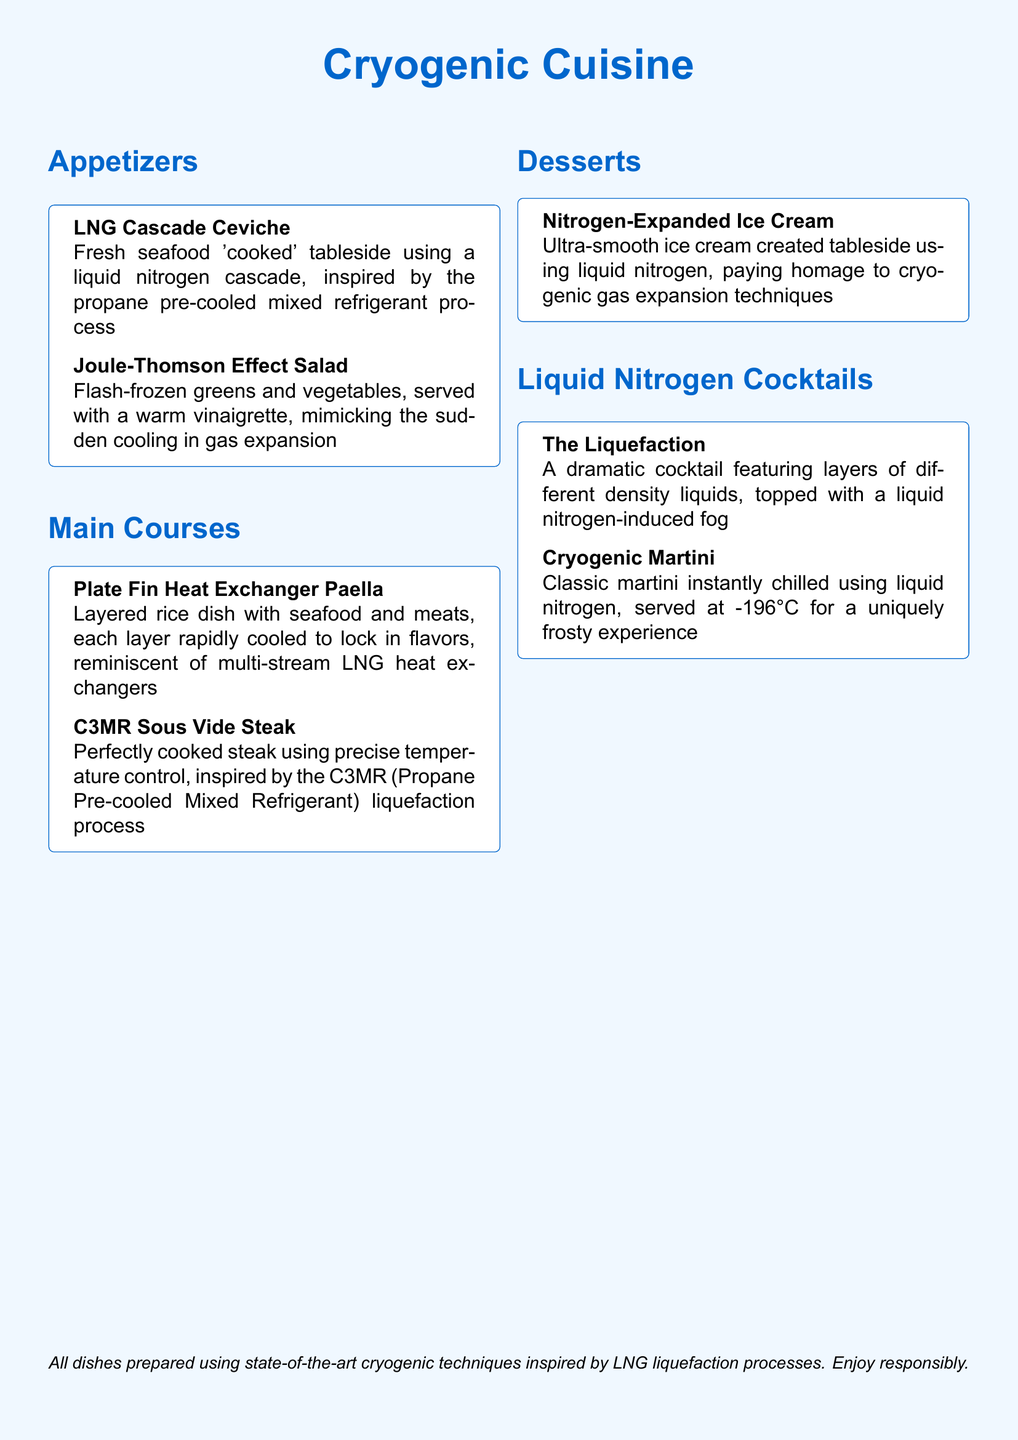What is the name of the first appetizer? The first appetizer listed is "LNG Cascade Ceviche."
Answer: LNG Cascade Ceviche How is the "Joule-Thomson Effect Salad" prepared? The salad is flash-frozen and served with a warm vinaigrette to mimic gas expansion cooling.
Answer: Flash-frozen What inspired the "C3MR Sous Vide Steak" dish? The dish is inspired by the C3MR (Propane Pre-cooled Mixed Refrigerant) liquefaction process.
Answer: C3MR liquefaction Which dessert uses liquid nitrogen in its preparation? The "Nitrogen-Expanded Ice Cream" is created using liquid nitrogen.
Answer: Nitrogen-Expanded Ice Cream What unique feature does "The Liquefaction" cocktail have? The cocktail features layers of different density liquids topped with fog from liquid nitrogen.
Answer: Fog What is the serving temperature of the "Cryogenic Martini"? The cocktail is served at -196°C.
Answer: -196°C How many categories are there in the menu? The menu includes four categories: Appetizers, Main Courses, Desserts, and Liquid Nitrogen Cocktails.
Answer: Four What is the theme of the restaurant menu? The theme is inspired by industrial cooling processes and LNG liquefaction.
Answer: Cryogenic Cuisine 